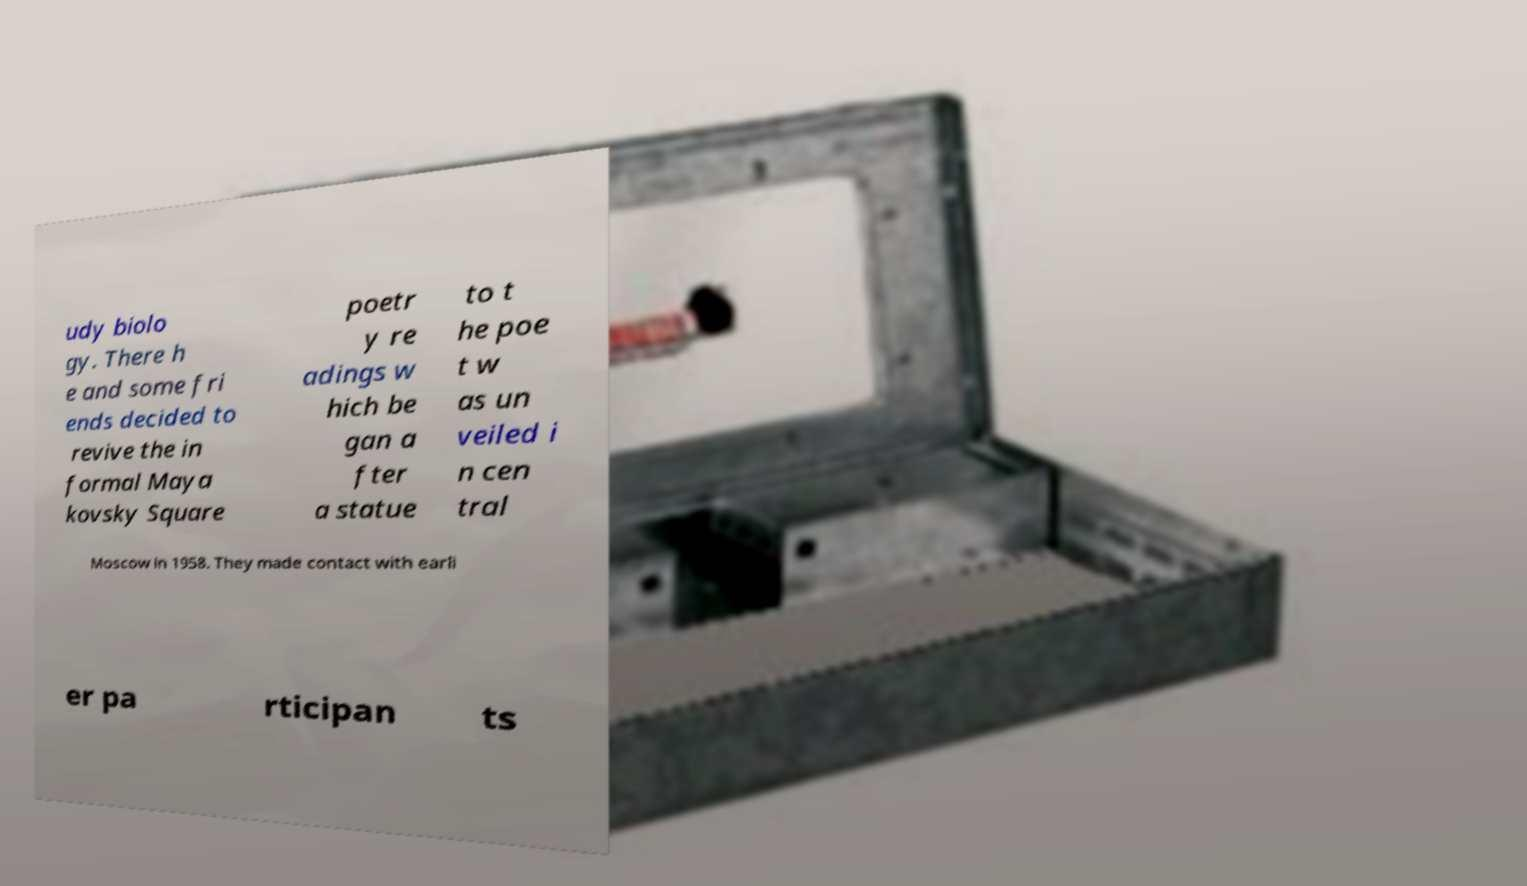Please identify and transcribe the text found in this image. udy biolo gy. There h e and some fri ends decided to revive the in formal Maya kovsky Square poetr y re adings w hich be gan a fter a statue to t he poe t w as un veiled i n cen tral Moscow in 1958. They made contact with earli er pa rticipan ts 